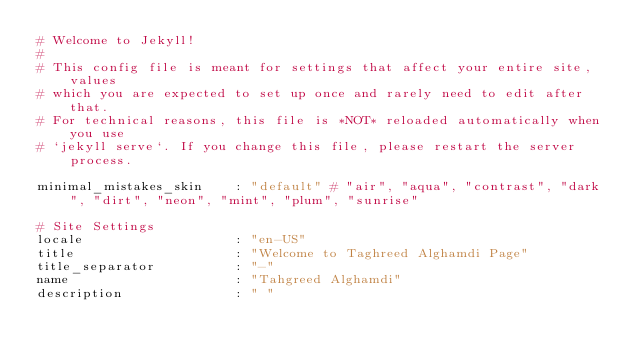<code> <loc_0><loc_0><loc_500><loc_500><_YAML_># Welcome to Jekyll!
#
# This config file is meant for settings that affect your entire site, values
# which you are expected to set up once and rarely need to edit after that.
# For technical reasons, this file is *NOT* reloaded automatically when you use
# `jekyll serve`. If you change this file, please restart the server process.

minimal_mistakes_skin    : "default" # "air", "aqua", "contrast", "dark", "dirt", "neon", "mint", "plum", "sunrise"

# Site Settings
locale                   : "en-US"
title                    : "Welcome to Taghreed Alghamdi Page"
title_separator          : "-"
name                     : "Tahgreed Alghamdi"
description              : " "</code> 